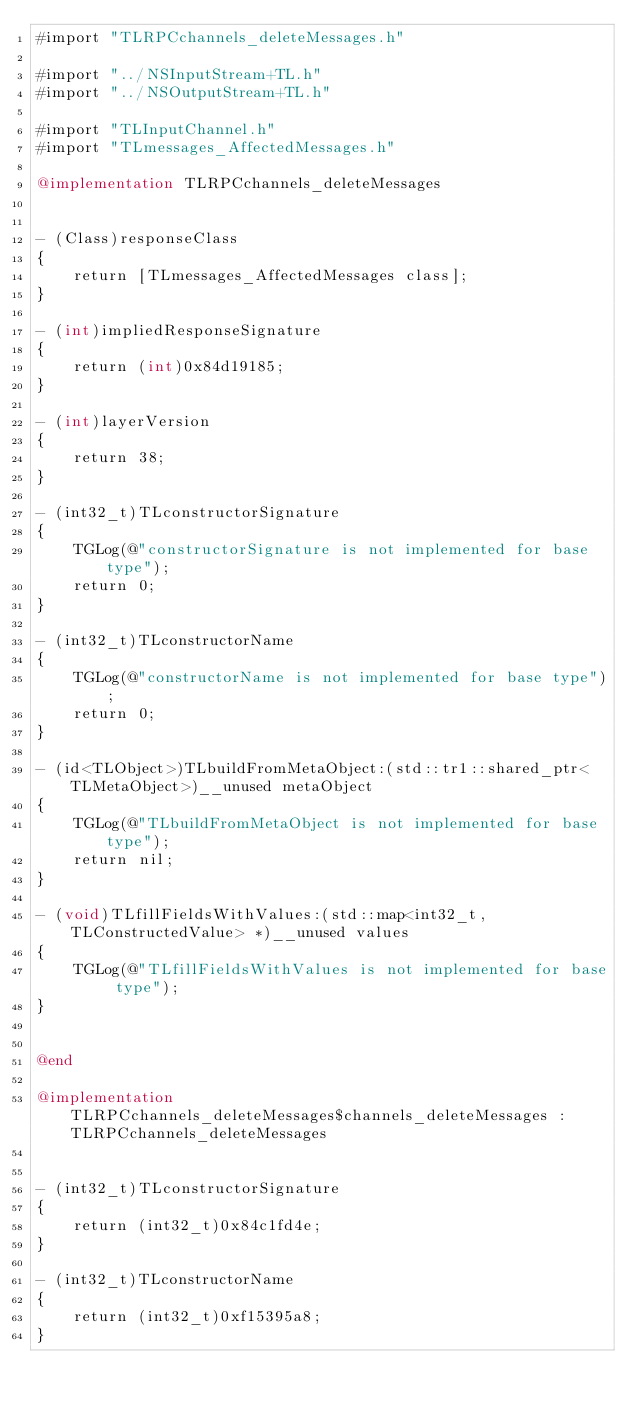<code> <loc_0><loc_0><loc_500><loc_500><_ObjectiveC_>#import "TLRPCchannels_deleteMessages.h"

#import "../NSInputStream+TL.h"
#import "../NSOutputStream+TL.h"

#import "TLInputChannel.h"
#import "TLmessages_AffectedMessages.h"

@implementation TLRPCchannels_deleteMessages


- (Class)responseClass
{
    return [TLmessages_AffectedMessages class];
}

- (int)impliedResponseSignature
{
    return (int)0x84d19185;
}

- (int)layerVersion
{
    return 38;
}

- (int32_t)TLconstructorSignature
{
    TGLog(@"constructorSignature is not implemented for base type");
    return 0;
}

- (int32_t)TLconstructorName
{
    TGLog(@"constructorName is not implemented for base type");
    return 0;
}

- (id<TLObject>)TLbuildFromMetaObject:(std::tr1::shared_ptr<TLMetaObject>)__unused metaObject
{
    TGLog(@"TLbuildFromMetaObject is not implemented for base type");
    return nil;
}

- (void)TLfillFieldsWithValues:(std::map<int32_t, TLConstructedValue> *)__unused values
{
    TGLog(@"TLfillFieldsWithValues is not implemented for base type");
}


@end

@implementation TLRPCchannels_deleteMessages$channels_deleteMessages : TLRPCchannels_deleteMessages


- (int32_t)TLconstructorSignature
{
    return (int32_t)0x84c1fd4e;
}

- (int32_t)TLconstructorName
{
    return (int32_t)0xf15395a8;
}
</code> 